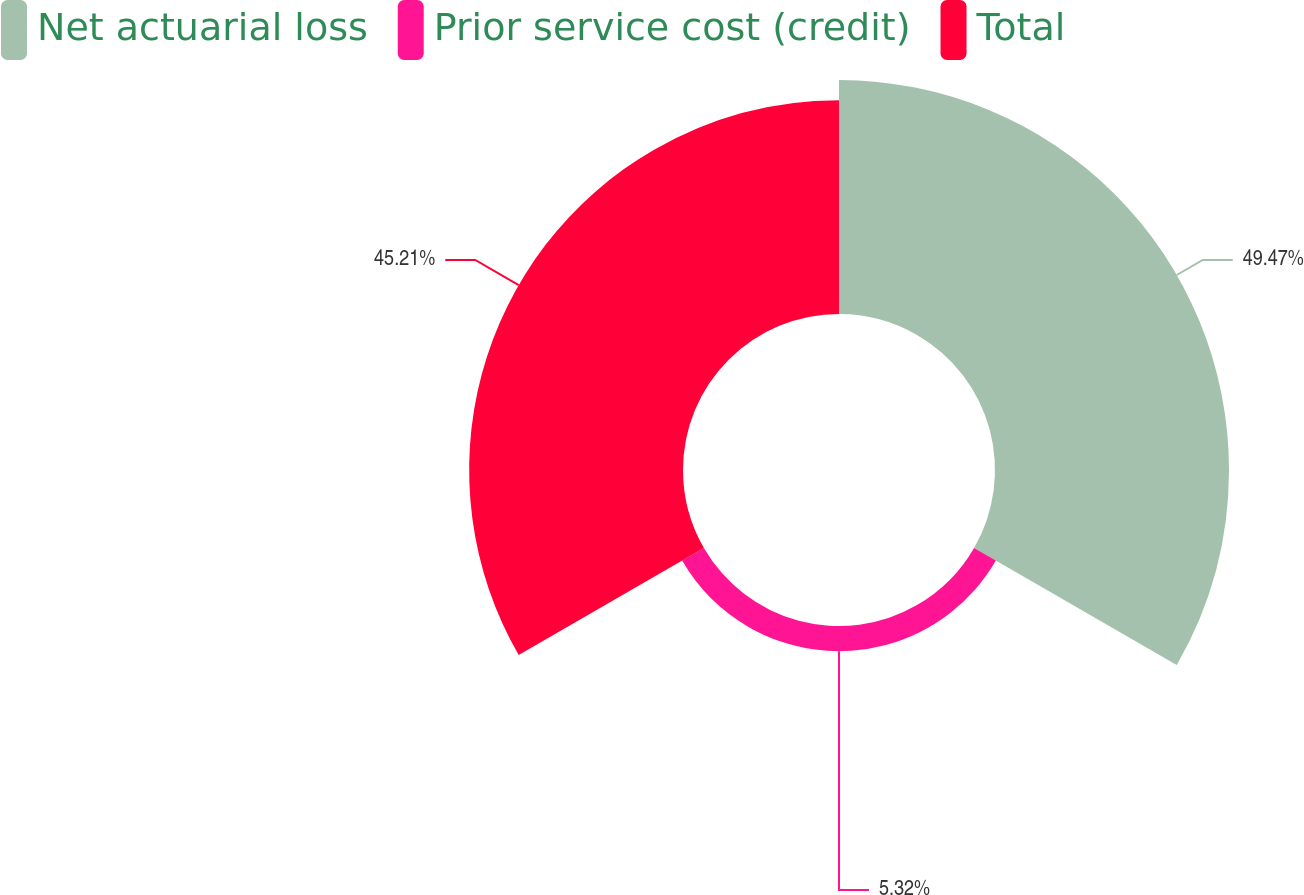Convert chart to OTSL. <chart><loc_0><loc_0><loc_500><loc_500><pie_chart><fcel>Net actuarial loss<fcel>Prior service cost (credit)<fcel>Total<nl><fcel>49.47%<fcel>5.32%<fcel>45.21%<nl></chart> 